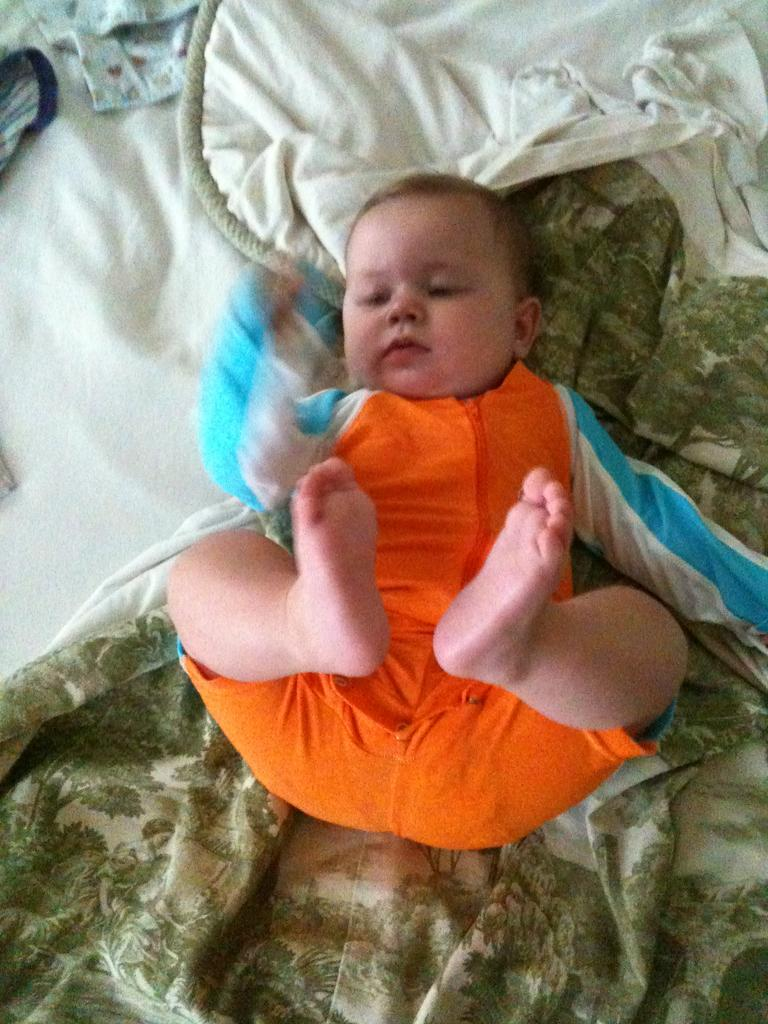What is the main subject of the image? There is a baby in the image. What else can be seen in the image besides the baby? There are clothes in the image. What story is the baby telling with their toes in the image? There is no story being told with the baby's toes in the image, as the toes are not depicted as communicating any narrative. 